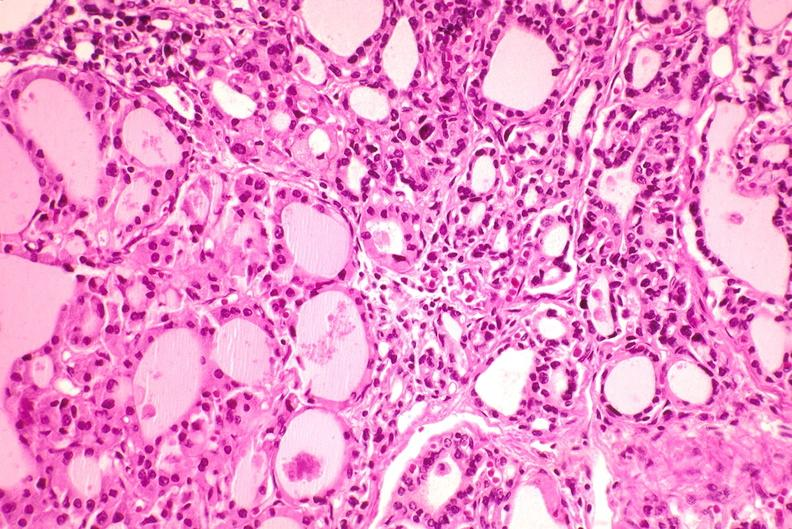does typical tuberculous exudate show thyroid, hashimoto 's?
Answer the question using a single word or phrase. No 